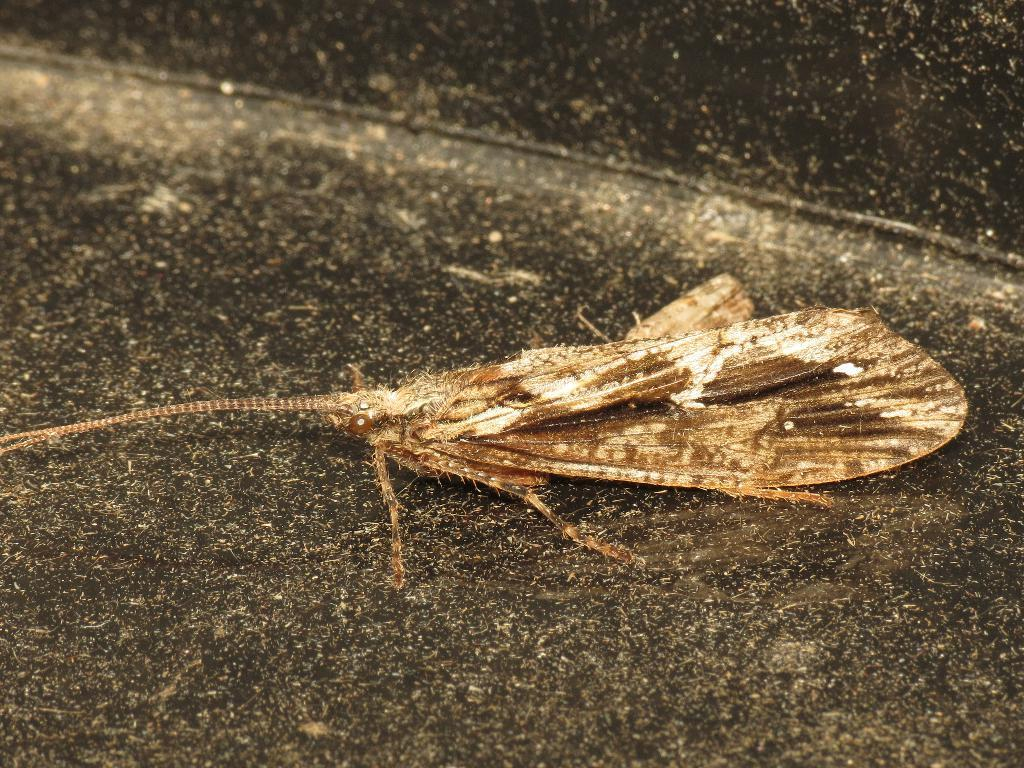What is the main subject of the image? The main subject of the image is a fly. Where is the fly located in the image? The fly is on the ground in the image. Can you describe the position of the fly in the image? The fly is in the center of the image. What type of letters does the fly's owner write in the image? There is no indication of a fly's owner or any letters in the image. 